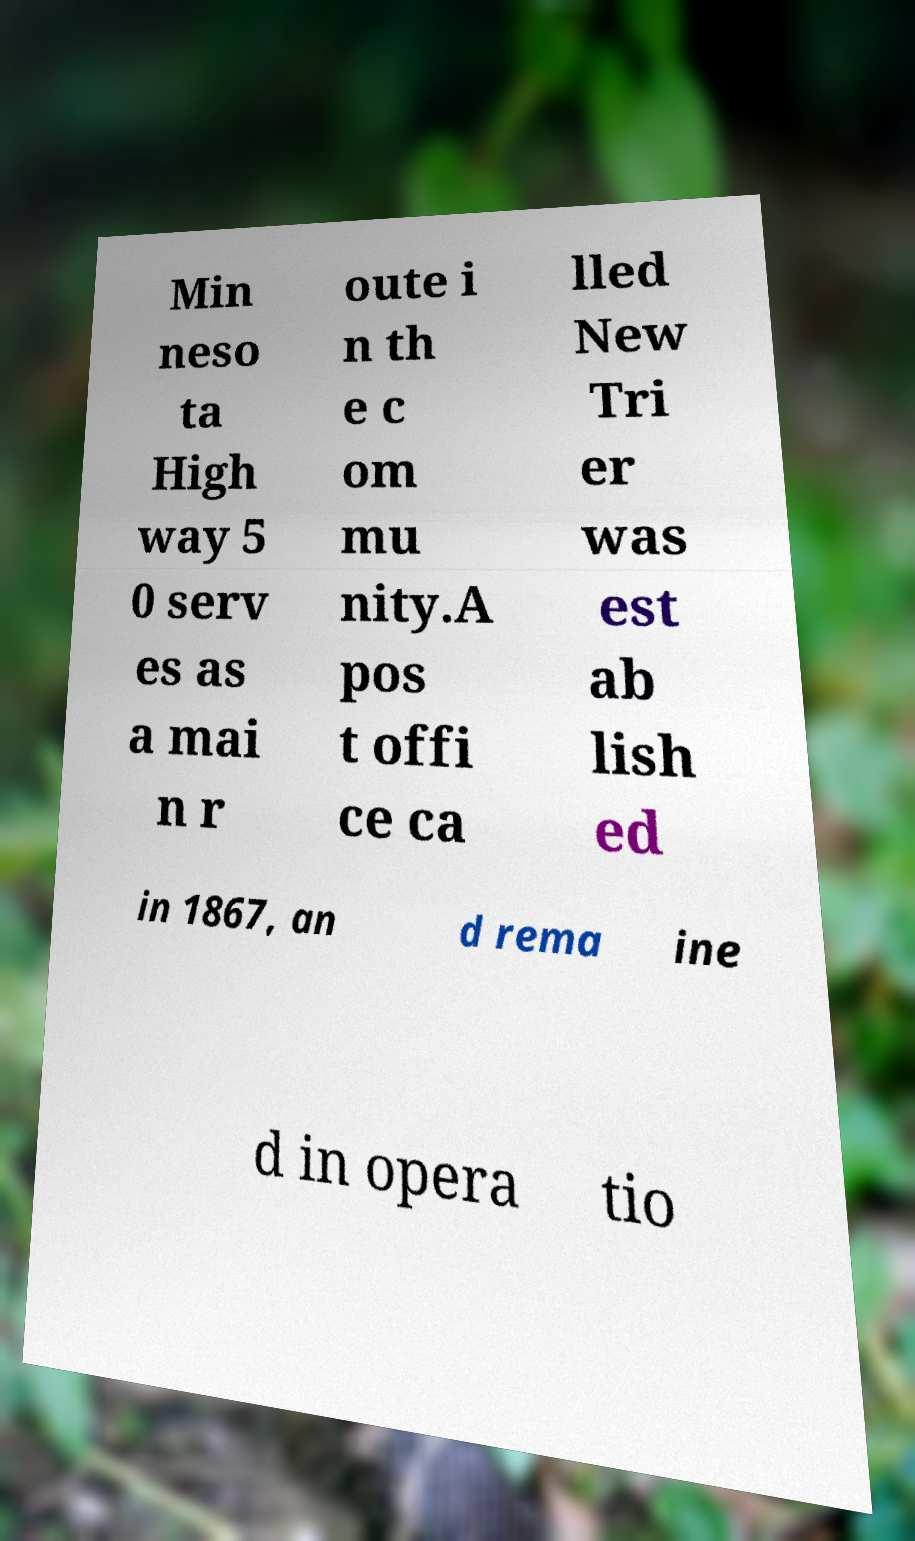I need the written content from this picture converted into text. Can you do that? Min neso ta High way 5 0 serv es as a mai n r oute i n th e c om mu nity.A pos t offi ce ca lled New Tri er was est ab lish ed in 1867, an d rema ine d in opera tio 